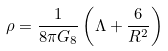Convert formula to latex. <formula><loc_0><loc_0><loc_500><loc_500>\rho = \frac { 1 } { 8 \pi G _ { 8 } } \left ( \Lambda + \frac { 6 } { R ^ { 2 } } \right )</formula> 